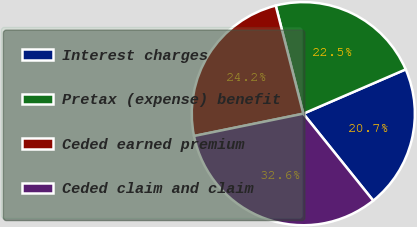Convert chart. <chart><loc_0><loc_0><loc_500><loc_500><pie_chart><fcel>Interest charges<fcel>Pretax (expense) benefit<fcel>Ceded earned premium<fcel>Ceded claim and claim<nl><fcel>20.72%<fcel>22.48%<fcel>24.23%<fcel>32.57%<nl></chart> 